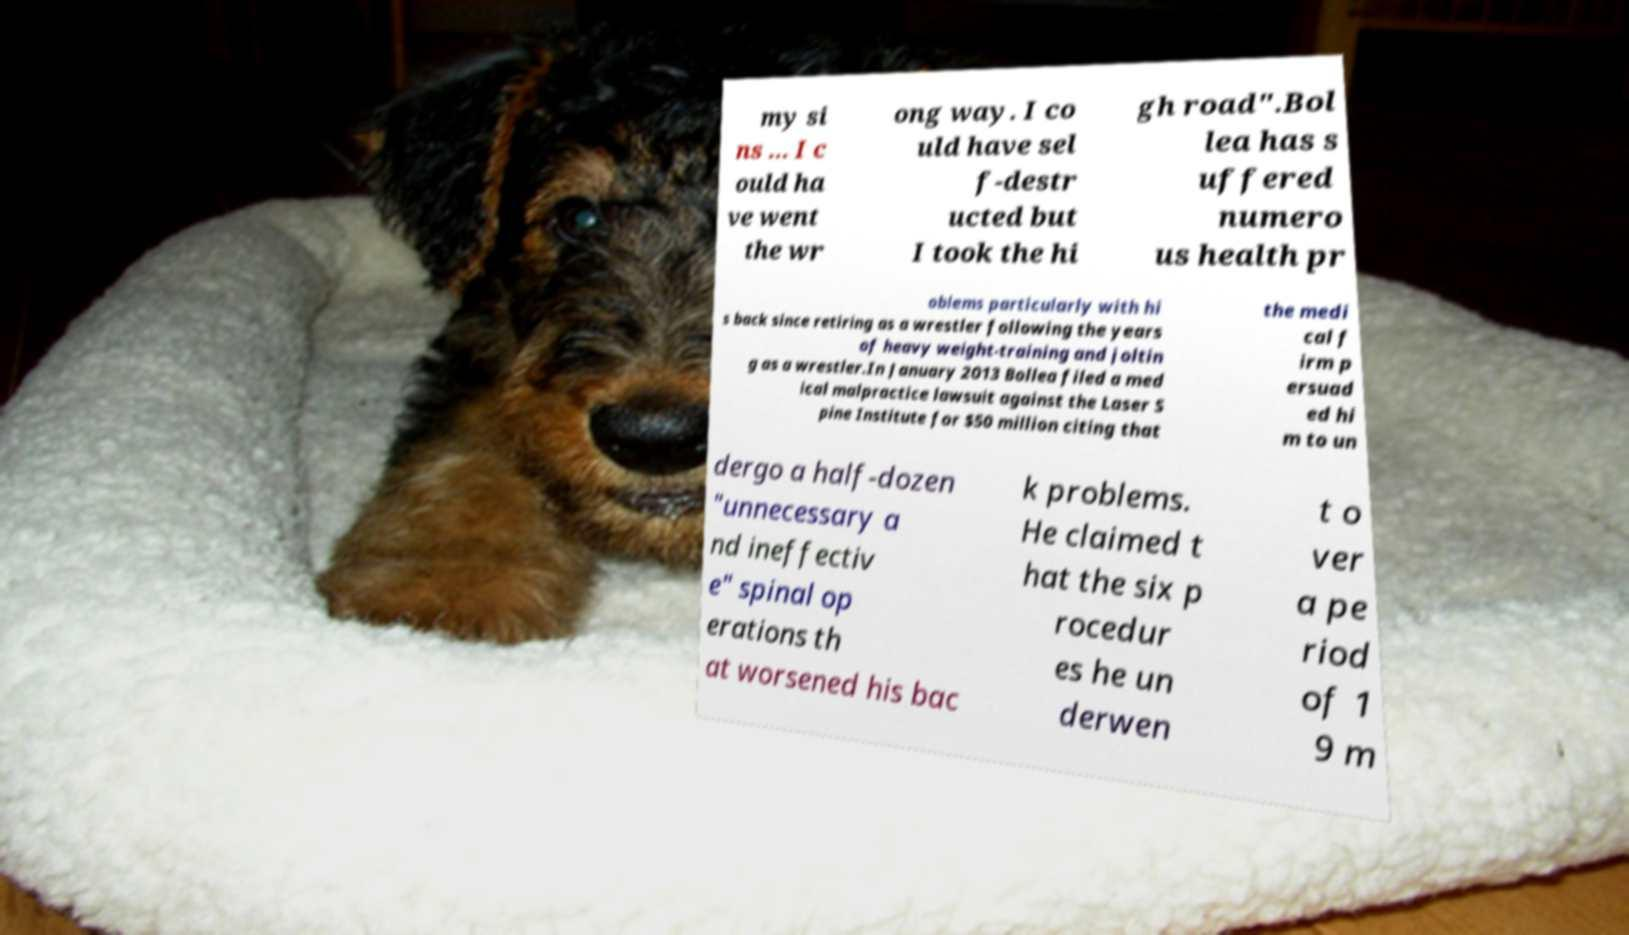There's text embedded in this image that I need extracted. Can you transcribe it verbatim? my si ns ... I c ould ha ve went the wr ong way. I co uld have sel f-destr ucted but I took the hi gh road".Bol lea has s uffered numero us health pr oblems particularly with hi s back since retiring as a wrestler following the years of heavy weight-training and joltin g as a wrestler.In January 2013 Bollea filed a med ical malpractice lawsuit against the Laser S pine Institute for $50 million citing that the medi cal f irm p ersuad ed hi m to un dergo a half-dozen "unnecessary a nd ineffectiv e" spinal op erations th at worsened his bac k problems. He claimed t hat the six p rocedur es he un derwen t o ver a pe riod of 1 9 m 